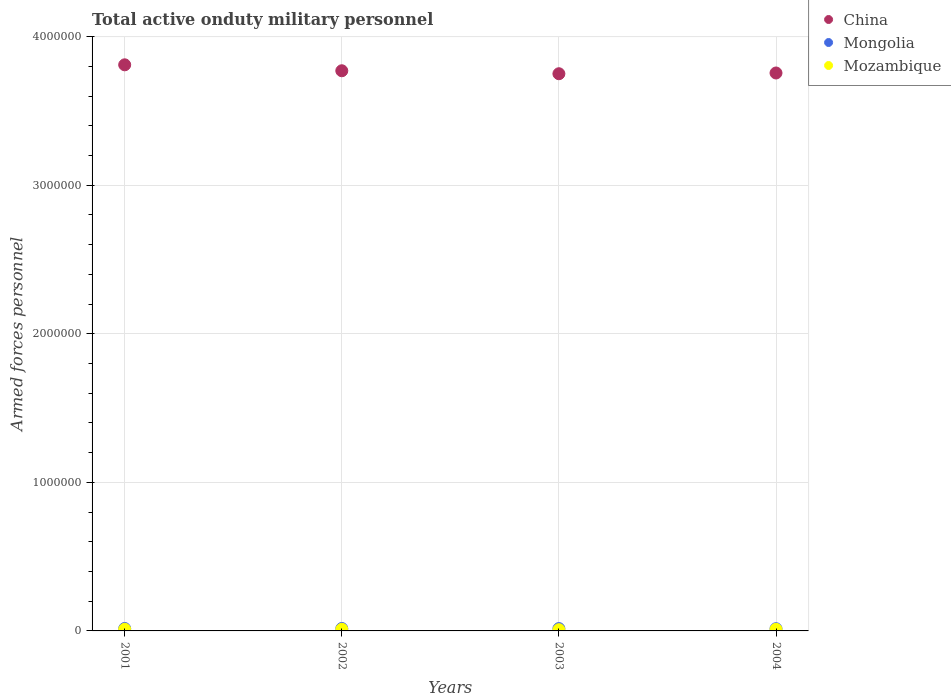How many different coloured dotlines are there?
Your answer should be compact. 3. What is the number of armed forces personnel in Mozambique in 2001?
Ensure brevity in your answer.  1.10e+04. Across all years, what is the maximum number of armed forces personnel in Mozambique?
Your answer should be compact. 1.10e+04. Across all years, what is the minimum number of armed forces personnel in Mongolia?
Make the answer very short. 1.50e+04. In which year was the number of armed forces personnel in Mozambique maximum?
Offer a terse response. 2001. In which year was the number of armed forces personnel in China minimum?
Your answer should be compact. 2003. What is the total number of armed forces personnel in Mozambique in the graph?
Provide a short and direct response. 4.12e+04. What is the difference between the number of armed forces personnel in Mongolia in 2003 and that in 2004?
Keep it short and to the point. 800. What is the difference between the number of armed forces personnel in Mongolia in 2002 and the number of armed forces personnel in Mozambique in 2003?
Offer a very short reply. 8100. What is the average number of armed forces personnel in China per year?
Give a very brief answer. 3.77e+06. In the year 2003, what is the difference between the number of armed forces personnel in Mongolia and number of armed forces personnel in China?
Give a very brief answer. -3.73e+06. What is the ratio of the number of armed forces personnel in Mongolia in 2001 to that in 2004?
Offer a terse response. 1.09. Is the number of armed forces personnel in Mongolia in 2002 less than that in 2004?
Make the answer very short. No. What is the difference between the highest and the lowest number of armed forces personnel in China?
Offer a very short reply. 6.00e+04. In how many years, is the number of armed forces personnel in Mozambique greater than the average number of armed forces personnel in Mozambique taken over all years?
Ensure brevity in your answer.  3. Is the sum of the number of armed forces personnel in Mozambique in 2001 and 2004 greater than the maximum number of armed forces personnel in China across all years?
Keep it short and to the point. No. Is it the case that in every year, the sum of the number of armed forces personnel in China and number of armed forces personnel in Mongolia  is greater than the number of armed forces personnel in Mozambique?
Provide a succinct answer. Yes. Does the number of armed forces personnel in Mozambique monotonically increase over the years?
Provide a short and direct response. No. How many dotlines are there?
Make the answer very short. 3. What is the difference between two consecutive major ticks on the Y-axis?
Make the answer very short. 1.00e+06. Does the graph contain any zero values?
Offer a very short reply. No. Does the graph contain grids?
Offer a terse response. Yes. How many legend labels are there?
Your response must be concise. 3. What is the title of the graph?
Provide a succinct answer. Total active onduty military personnel. Does "Niger" appear as one of the legend labels in the graph?
Provide a succinct answer. No. What is the label or title of the X-axis?
Keep it short and to the point. Years. What is the label or title of the Y-axis?
Your answer should be very brief. Armed forces personnel. What is the Armed forces personnel in China in 2001?
Provide a short and direct response. 3.81e+06. What is the Armed forces personnel in Mongolia in 2001?
Your response must be concise. 1.63e+04. What is the Armed forces personnel of Mozambique in 2001?
Keep it short and to the point. 1.10e+04. What is the Armed forces personnel of China in 2002?
Offer a terse response. 3.77e+06. What is the Armed forces personnel in Mongolia in 2002?
Provide a short and direct response. 1.63e+04. What is the Armed forces personnel in Mozambique in 2002?
Your answer should be very brief. 1.10e+04. What is the Armed forces personnel in China in 2003?
Offer a very short reply. 3.75e+06. What is the Armed forces personnel of Mongolia in 2003?
Offer a very short reply. 1.58e+04. What is the Armed forces personnel in Mozambique in 2003?
Keep it short and to the point. 8200. What is the Armed forces personnel in China in 2004?
Give a very brief answer. 3.76e+06. What is the Armed forces personnel in Mongolia in 2004?
Offer a terse response. 1.50e+04. What is the Armed forces personnel in Mozambique in 2004?
Make the answer very short. 1.10e+04. Across all years, what is the maximum Armed forces personnel of China?
Keep it short and to the point. 3.81e+06. Across all years, what is the maximum Armed forces personnel of Mongolia?
Provide a succinct answer. 1.63e+04. Across all years, what is the maximum Armed forces personnel in Mozambique?
Provide a short and direct response. 1.10e+04. Across all years, what is the minimum Armed forces personnel in China?
Offer a terse response. 3.75e+06. Across all years, what is the minimum Armed forces personnel in Mongolia?
Provide a succinct answer. 1.50e+04. Across all years, what is the minimum Armed forces personnel of Mozambique?
Your answer should be very brief. 8200. What is the total Armed forces personnel of China in the graph?
Provide a succinct answer. 1.51e+07. What is the total Armed forces personnel of Mongolia in the graph?
Provide a short and direct response. 6.34e+04. What is the total Armed forces personnel in Mozambique in the graph?
Your answer should be very brief. 4.12e+04. What is the difference between the Armed forces personnel in Mozambique in 2001 and that in 2002?
Offer a terse response. 0. What is the difference between the Armed forces personnel of Mongolia in 2001 and that in 2003?
Give a very brief answer. 500. What is the difference between the Armed forces personnel in Mozambique in 2001 and that in 2003?
Provide a succinct answer. 2800. What is the difference between the Armed forces personnel in China in 2001 and that in 2004?
Give a very brief answer. 5.50e+04. What is the difference between the Armed forces personnel in Mongolia in 2001 and that in 2004?
Provide a succinct answer. 1300. What is the difference between the Armed forces personnel of Mozambique in 2001 and that in 2004?
Keep it short and to the point. 0. What is the difference between the Armed forces personnel in Mozambique in 2002 and that in 2003?
Keep it short and to the point. 2800. What is the difference between the Armed forces personnel of China in 2002 and that in 2004?
Provide a succinct answer. 1.50e+04. What is the difference between the Armed forces personnel of Mongolia in 2002 and that in 2004?
Make the answer very short. 1300. What is the difference between the Armed forces personnel in Mozambique in 2002 and that in 2004?
Make the answer very short. 0. What is the difference between the Armed forces personnel of China in 2003 and that in 2004?
Your response must be concise. -5000. What is the difference between the Armed forces personnel of Mongolia in 2003 and that in 2004?
Make the answer very short. 800. What is the difference between the Armed forces personnel in Mozambique in 2003 and that in 2004?
Your answer should be very brief. -2800. What is the difference between the Armed forces personnel of China in 2001 and the Armed forces personnel of Mongolia in 2002?
Offer a very short reply. 3.79e+06. What is the difference between the Armed forces personnel of China in 2001 and the Armed forces personnel of Mozambique in 2002?
Make the answer very short. 3.80e+06. What is the difference between the Armed forces personnel of Mongolia in 2001 and the Armed forces personnel of Mozambique in 2002?
Provide a short and direct response. 5300. What is the difference between the Armed forces personnel in China in 2001 and the Armed forces personnel in Mongolia in 2003?
Your answer should be very brief. 3.79e+06. What is the difference between the Armed forces personnel of China in 2001 and the Armed forces personnel of Mozambique in 2003?
Your answer should be compact. 3.80e+06. What is the difference between the Armed forces personnel in Mongolia in 2001 and the Armed forces personnel in Mozambique in 2003?
Offer a terse response. 8100. What is the difference between the Armed forces personnel in China in 2001 and the Armed forces personnel in Mongolia in 2004?
Offer a terse response. 3.80e+06. What is the difference between the Armed forces personnel in China in 2001 and the Armed forces personnel in Mozambique in 2004?
Offer a terse response. 3.80e+06. What is the difference between the Armed forces personnel in Mongolia in 2001 and the Armed forces personnel in Mozambique in 2004?
Offer a terse response. 5300. What is the difference between the Armed forces personnel in China in 2002 and the Armed forces personnel in Mongolia in 2003?
Offer a very short reply. 3.75e+06. What is the difference between the Armed forces personnel of China in 2002 and the Armed forces personnel of Mozambique in 2003?
Your answer should be compact. 3.76e+06. What is the difference between the Armed forces personnel in Mongolia in 2002 and the Armed forces personnel in Mozambique in 2003?
Make the answer very short. 8100. What is the difference between the Armed forces personnel in China in 2002 and the Armed forces personnel in Mongolia in 2004?
Your answer should be compact. 3.76e+06. What is the difference between the Armed forces personnel in China in 2002 and the Armed forces personnel in Mozambique in 2004?
Keep it short and to the point. 3.76e+06. What is the difference between the Armed forces personnel of Mongolia in 2002 and the Armed forces personnel of Mozambique in 2004?
Provide a short and direct response. 5300. What is the difference between the Armed forces personnel in China in 2003 and the Armed forces personnel in Mongolia in 2004?
Offer a very short reply. 3.74e+06. What is the difference between the Armed forces personnel of China in 2003 and the Armed forces personnel of Mozambique in 2004?
Provide a short and direct response. 3.74e+06. What is the difference between the Armed forces personnel of Mongolia in 2003 and the Armed forces personnel of Mozambique in 2004?
Your answer should be very brief. 4800. What is the average Armed forces personnel of China per year?
Your answer should be compact. 3.77e+06. What is the average Armed forces personnel in Mongolia per year?
Provide a succinct answer. 1.58e+04. What is the average Armed forces personnel of Mozambique per year?
Your response must be concise. 1.03e+04. In the year 2001, what is the difference between the Armed forces personnel of China and Armed forces personnel of Mongolia?
Provide a succinct answer. 3.79e+06. In the year 2001, what is the difference between the Armed forces personnel of China and Armed forces personnel of Mozambique?
Provide a succinct answer. 3.80e+06. In the year 2001, what is the difference between the Armed forces personnel of Mongolia and Armed forces personnel of Mozambique?
Keep it short and to the point. 5300. In the year 2002, what is the difference between the Armed forces personnel in China and Armed forces personnel in Mongolia?
Keep it short and to the point. 3.75e+06. In the year 2002, what is the difference between the Armed forces personnel in China and Armed forces personnel in Mozambique?
Your answer should be compact. 3.76e+06. In the year 2002, what is the difference between the Armed forces personnel in Mongolia and Armed forces personnel in Mozambique?
Keep it short and to the point. 5300. In the year 2003, what is the difference between the Armed forces personnel in China and Armed forces personnel in Mongolia?
Ensure brevity in your answer.  3.73e+06. In the year 2003, what is the difference between the Armed forces personnel in China and Armed forces personnel in Mozambique?
Your answer should be compact. 3.74e+06. In the year 2003, what is the difference between the Armed forces personnel of Mongolia and Armed forces personnel of Mozambique?
Your response must be concise. 7600. In the year 2004, what is the difference between the Armed forces personnel of China and Armed forces personnel of Mongolia?
Offer a terse response. 3.74e+06. In the year 2004, what is the difference between the Armed forces personnel of China and Armed forces personnel of Mozambique?
Give a very brief answer. 3.74e+06. In the year 2004, what is the difference between the Armed forces personnel of Mongolia and Armed forces personnel of Mozambique?
Provide a succinct answer. 4000. What is the ratio of the Armed forces personnel in China in 2001 to that in 2002?
Your response must be concise. 1.01. What is the ratio of the Armed forces personnel in Mongolia in 2001 to that in 2003?
Your response must be concise. 1.03. What is the ratio of the Armed forces personnel in Mozambique in 2001 to that in 2003?
Give a very brief answer. 1.34. What is the ratio of the Armed forces personnel in China in 2001 to that in 2004?
Make the answer very short. 1.01. What is the ratio of the Armed forces personnel of Mongolia in 2001 to that in 2004?
Your answer should be very brief. 1.09. What is the ratio of the Armed forces personnel in Mozambique in 2001 to that in 2004?
Your answer should be compact. 1. What is the ratio of the Armed forces personnel of Mongolia in 2002 to that in 2003?
Ensure brevity in your answer.  1.03. What is the ratio of the Armed forces personnel of Mozambique in 2002 to that in 2003?
Offer a very short reply. 1.34. What is the ratio of the Armed forces personnel in Mongolia in 2002 to that in 2004?
Offer a very short reply. 1.09. What is the ratio of the Armed forces personnel in Mozambique in 2002 to that in 2004?
Your answer should be very brief. 1. What is the ratio of the Armed forces personnel of Mongolia in 2003 to that in 2004?
Keep it short and to the point. 1.05. What is the ratio of the Armed forces personnel of Mozambique in 2003 to that in 2004?
Keep it short and to the point. 0.75. What is the difference between the highest and the second highest Armed forces personnel of China?
Ensure brevity in your answer.  4.00e+04. What is the difference between the highest and the second highest Armed forces personnel of Mongolia?
Your answer should be very brief. 0. What is the difference between the highest and the lowest Armed forces personnel in China?
Make the answer very short. 6.00e+04. What is the difference between the highest and the lowest Armed forces personnel in Mongolia?
Offer a very short reply. 1300. What is the difference between the highest and the lowest Armed forces personnel in Mozambique?
Offer a terse response. 2800. 